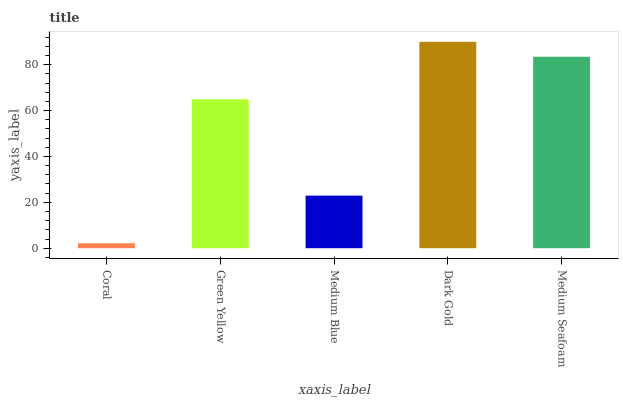Is Green Yellow the minimum?
Answer yes or no. No. Is Green Yellow the maximum?
Answer yes or no. No. Is Green Yellow greater than Coral?
Answer yes or no. Yes. Is Coral less than Green Yellow?
Answer yes or no. Yes. Is Coral greater than Green Yellow?
Answer yes or no. No. Is Green Yellow less than Coral?
Answer yes or no. No. Is Green Yellow the high median?
Answer yes or no. Yes. Is Green Yellow the low median?
Answer yes or no. Yes. Is Dark Gold the high median?
Answer yes or no. No. Is Coral the low median?
Answer yes or no. No. 